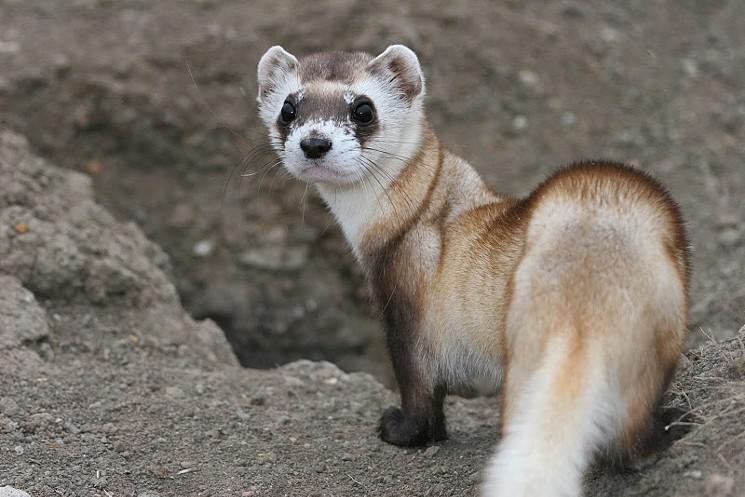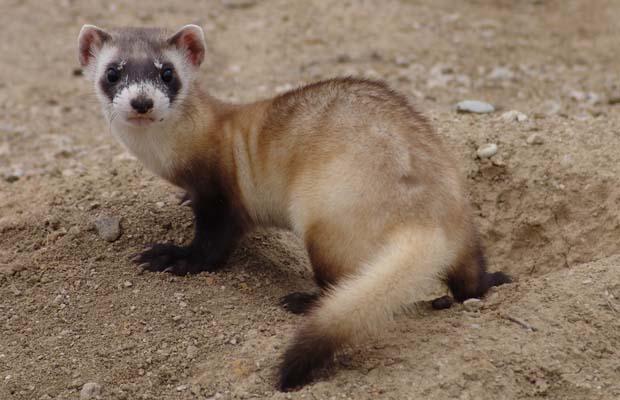The first image is the image on the left, the second image is the image on the right. Analyze the images presented: Is the assertion "There are at most two ferrets." valid? Answer yes or no. Yes. The first image is the image on the left, the second image is the image on the right. For the images shown, is this caption "Each image shows a single ferret, and each ferrret is standing on all fours and looking toward the camera." true? Answer yes or no. Yes. The first image is the image on the left, the second image is the image on the right. Analyze the images presented: Is the assertion "There are exactly two ferrets with heads facing directly at the camera." valid? Answer yes or no. Yes. The first image is the image on the left, the second image is the image on the right. Examine the images to the left and right. Is the description "There are at least three total rodents." accurate? Answer yes or no. No. 